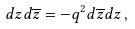<formula> <loc_0><loc_0><loc_500><loc_500>d z d \overline { z } = - q ^ { 2 } d \overline { z } d z \, ,</formula> 